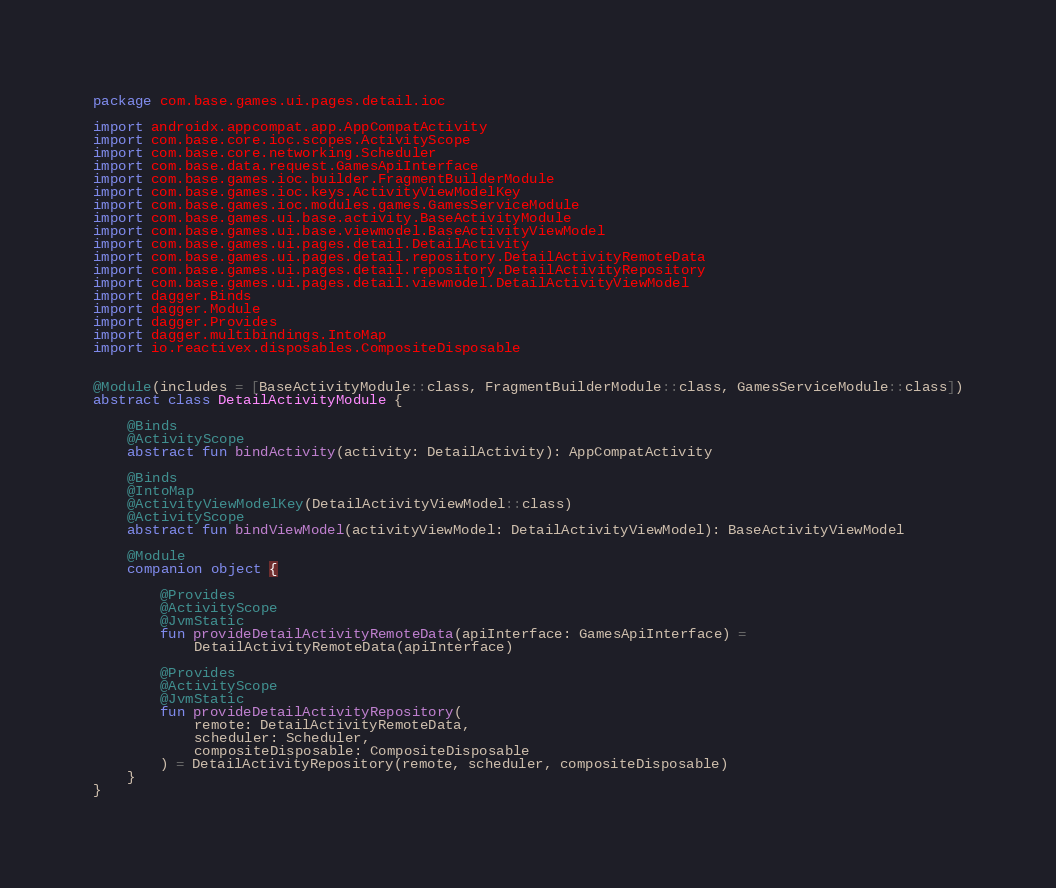Convert code to text. <code><loc_0><loc_0><loc_500><loc_500><_Kotlin_>package com.base.games.ui.pages.detail.ioc

import androidx.appcompat.app.AppCompatActivity
import com.base.core.ioc.scopes.ActivityScope
import com.base.core.networking.Scheduler
import com.base.data.request.GamesApiInterface
import com.base.games.ioc.builder.FragmentBuilderModule
import com.base.games.ioc.keys.ActivityViewModelKey
import com.base.games.ioc.modules.games.GamesServiceModule
import com.base.games.ui.base.activity.BaseActivityModule
import com.base.games.ui.base.viewmodel.BaseActivityViewModel
import com.base.games.ui.pages.detail.DetailActivity
import com.base.games.ui.pages.detail.repository.DetailActivityRemoteData
import com.base.games.ui.pages.detail.repository.DetailActivityRepository
import com.base.games.ui.pages.detail.viewmodel.DetailActivityViewModel
import dagger.Binds
import dagger.Module
import dagger.Provides
import dagger.multibindings.IntoMap
import io.reactivex.disposables.CompositeDisposable


@Module(includes = [BaseActivityModule::class, FragmentBuilderModule::class, GamesServiceModule::class])
abstract class DetailActivityModule {

    @Binds
    @ActivityScope
    abstract fun bindActivity(activity: DetailActivity): AppCompatActivity

    @Binds
    @IntoMap
    @ActivityViewModelKey(DetailActivityViewModel::class)
    @ActivityScope
    abstract fun bindViewModel(activityViewModel: DetailActivityViewModel): BaseActivityViewModel

    @Module
    companion object {

        @Provides
        @ActivityScope
        @JvmStatic
        fun provideDetailActivityRemoteData(apiInterface: GamesApiInterface) =
            DetailActivityRemoteData(apiInterface)

        @Provides
        @ActivityScope
        @JvmStatic
        fun provideDetailActivityRepository(
            remote: DetailActivityRemoteData,
            scheduler: Scheduler,
            compositeDisposable: CompositeDisposable
        ) = DetailActivityRepository(remote, scheduler, compositeDisposable)
    }
}</code> 